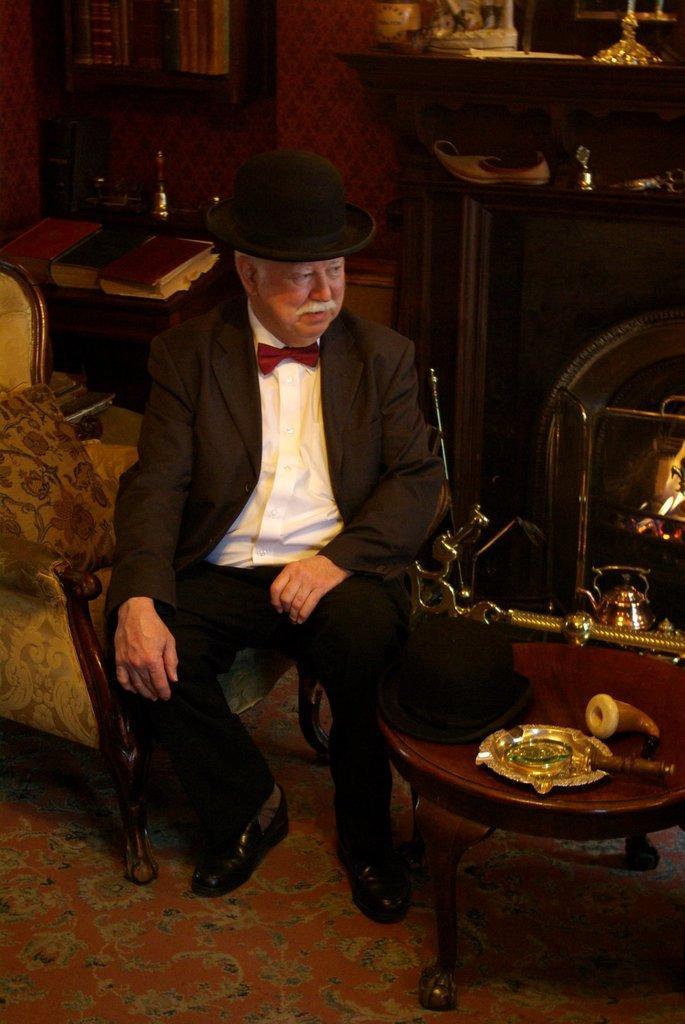Can you describe this image briefly? This picture shows a man seated on a chair and he wore a hat on his head And he wore a black suit And a black shoe 